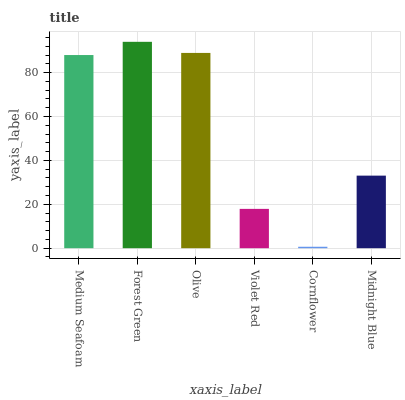Is Cornflower the minimum?
Answer yes or no. Yes. Is Forest Green the maximum?
Answer yes or no. Yes. Is Olive the minimum?
Answer yes or no. No. Is Olive the maximum?
Answer yes or no. No. Is Forest Green greater than Olive?
Answer yes or no. Yes. Is Olive less than Forest Green?
Answer yes or no. Yes. Is Olive greater than Forest Green?
Answer yes or no. No. Is Forest Green less than Olive?
Answer yes or no. No. Is Medium Seafoam the high median?
Answer yes or no. Yes. Is Midnight Blue the low median?
Answer yes or no. Yes. Is Violet Red the high median?
Answer yes or no. No. Is Cornflower the low median?
Answer yes or no. No. 